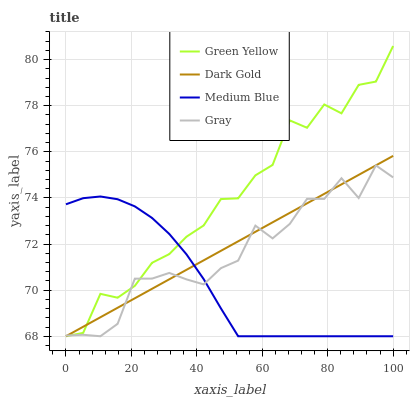Does Medium Blue have the minimum area under the curve?
Answer yes or no. Yes. Does Green Yellow have the maximum area under the curve?
Answer yes or no. Yes. Does Green Yellow have the minimum area under the curve?
Answer yes or no. No. Does Medium Blue have the maximum area under the curve?
Answer yes or no. No. Is Dark Gold the smoothest?
Answer yes or no. Yes. Is Green Yellow the roughest?
Answer yes or no. Yes. Is Medium Blue the smoothest?
Answer yes or no. No. Is Medium Blue the roughest?
Answer yes or no. No. Does Gray have the lowest value?
Answer yes or no. Yes. Does Green Yellow have the highest value?
Answer yes or no. Yes. Does Medium Blue have the highest value?
Answer yes or no. No. Does Dark Gold intersect Green Yellow?
Answer yes or no. Yes. Is Dark Gold less than Green Yellow?
Answer yes or no. No. Is Dark Gold greater than Green Yellow?
Answer yes or no. No. 